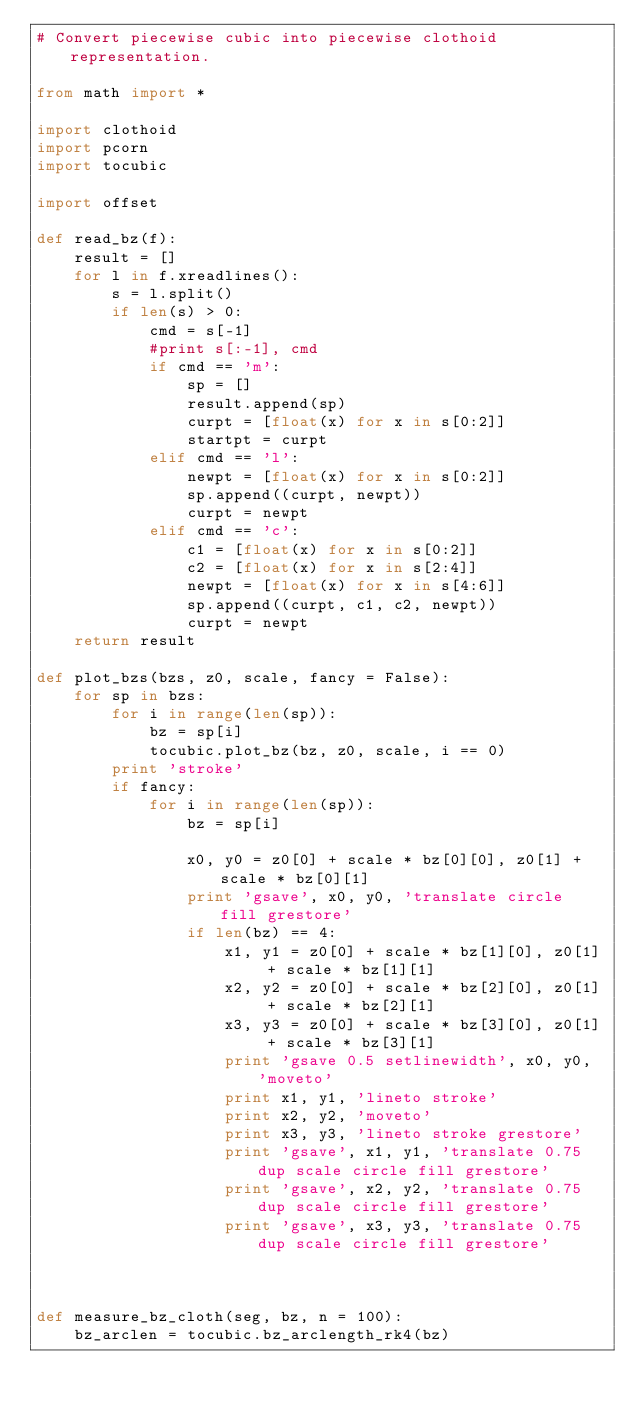Convert code to text. <code><loc_0><loc_0><loc_500><loc_500><_Python_># Convert piecewise cubic into piecewise clothoid representation.

from math import *

import clothoid
import pcorn
import tocubic

import offset

def read_bz(f):
    result = []
    for l in f.xreadlines():
        s = l.split()
        if len(s) > 0:
            cmd = s[-1]
            #print s[:-1], cmd
            if cmd == 'm':
                sp = []
                result.append(sp)
                curpt = [float(x) for x in s[0:2]]
                startpt = curpt
            elif cmd == 'l':
                newpt = [float(x) for x in s[0:2]]
                sp.append((curpt, newpt))
                curpt = newpt
            elif cmd == 'c':
                c1 = [float(x) for x in s[0:2]]
                c2 = [float(x) for x in s[2:4]]
                newpt = [float(x) for x in s[4:6]]
                sp.append((curpt, c1, c2, newpt))
                curpt = newpt
    return result

def plot_bzs(bzs, z0, scale, fancy = False):
    for sp in bzs:
        for i in range(len(sp)):
            bz = sp[i]
            tocubic.plot_bz(bz, z0, scale, i == 0)
        print 'stroke'
        if fancy:
            for i in range(len(sp)):
                bz = sp[i]

                x0, y0 = z0[0] + scale * bz[0][0], z0[1] + scale * bz[0][1]
                print 'gsave', x0, y0, 'translate circle fill grestore'
                if len(bz) == 4:
                    x1, y1 = z0[0] + scale * bz[1][0], z0[1] + scale * bz[1][1]
                    x2, y2 = z0[0] + scale * bz[2][0], z0[1] + scale * bz[2][1]
                    x3, y3 = z0[0] + scale * bz[3][0], z0[1] + scale * bz[3][1]
                    print 'gsave 0.5 setlinewidth', x0, y0, 'moveto'
                    print x1, y1, 'lineto stroke'
                    print x2, y2, 'moveto'
                    print x3, y3, 'lineto stroke grestore'
                    print 'gsave', x1, y1, 'translate 0.75 dup scale circle fill grestore'
                    print 'gsave', x2, y2, 'translate 0.75 dup scale circle fill grestore'
                    print 'gsave', x3, y3, 'translate 0.75 dup scale circle fill grestore'
            
        

def measure_bz_cloth(seg, bz, n = 100):
    bz_arclen = tocubic.bz_arclength_rk4(bz)</code> 